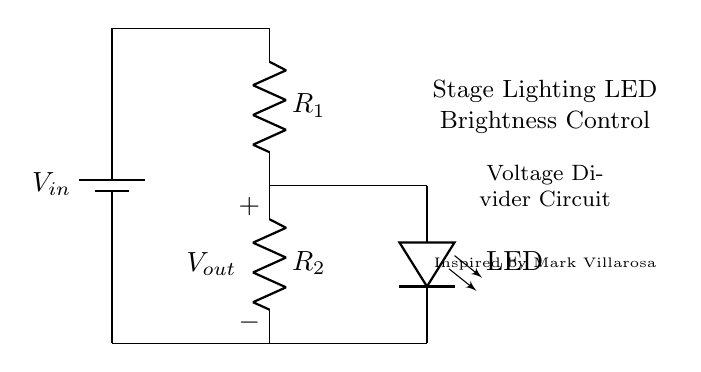What is the component labeled R1? The component labeled R1 is a resistor, which limits the current flowing through the circuit and is part of the voltage divider.
Answer: resistor What does Vout represent in this circuit? Vout represents the output voltage across R2, which in this configuration determines the brightness of the LED based on the resistor values.
Answer: output voltage How many resistors are present in the circuit? There are two resistors present, R1 and R2, which together form the voltage divider.
Answer: two What is the purpose of the LED in this circuit? The LED serves as an indicator for the output voltage and its brightness is controlled by the voltage divider created by R1 and R2.
Answer: indicator What is the configuration of R1 and R2? R1 and R2 are connected in series, which is essential for forming a voltage divider that outputs a portion of the input voltage.
Answer: series Which component controls the brightness of the LED? The brightness of the LED is controlled by R2 in the voltage divider, which determines how much voltage is dropped across it.
Answer: R2 What is the effect of increasing R1 on the LED brightness? Increasing R1 will decrease the output voltage Vout, resulting in a dimmer LED since there will be less voltage across R2.
Answer: dimmer LED 